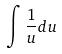<formula> <loc_0><loc_0><loc_500><loc_500>\int \frac { 1 } { u } d u</formula> 